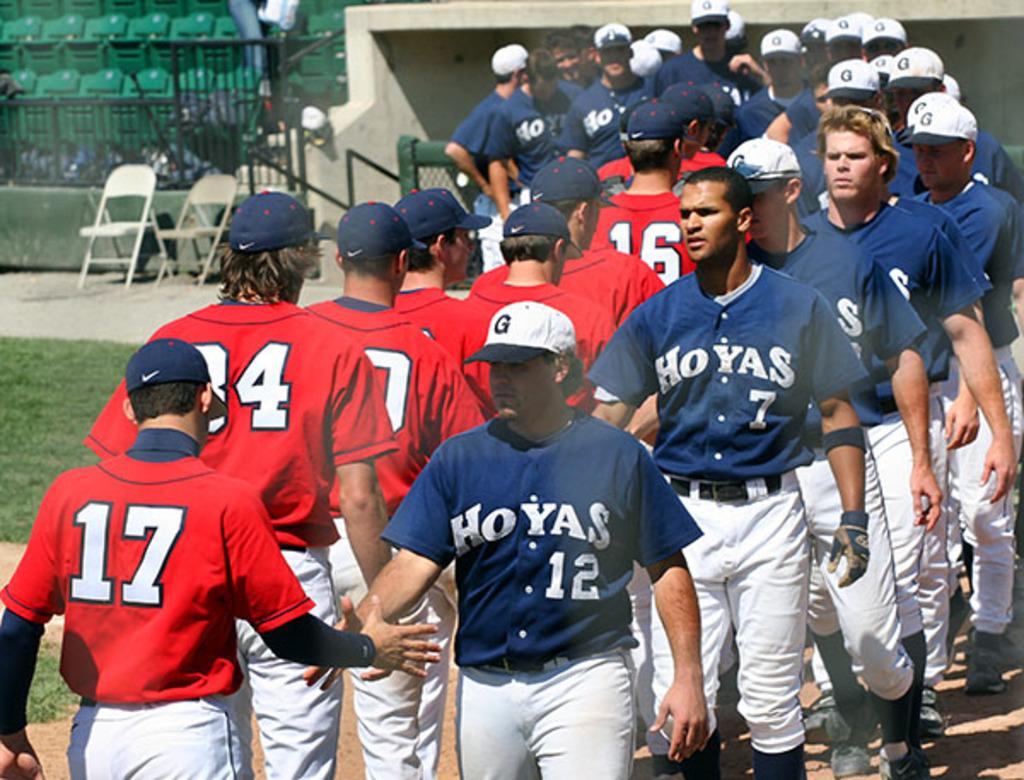Provide a one-sentence caption for the provided image. A Hoyas baseball team walking in a line and shaking hands with the members of another team. 